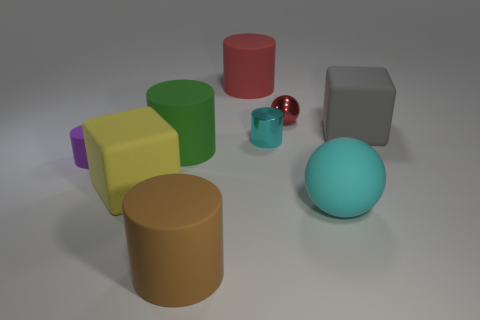Subtract all purple cylinders. How many cylinders are left? 4 Subtract all small purple cylinders. How many cylinders are left? 4 Subtract all blue cylinders. Subtract all red balls. How many cylinders are left? 5 Subtract all cubes. How many objects are left? 7 Add 4 metallic cylinders. How many metallic cylinders are left? 5 Add 7 yellow things. How many yellow things exist? 8 Subtract 1 purple cylinders. How many objects are left? 8 Subtract all tiny purple metal spheres. Subtract all small red balls. How many objects are left? 8 